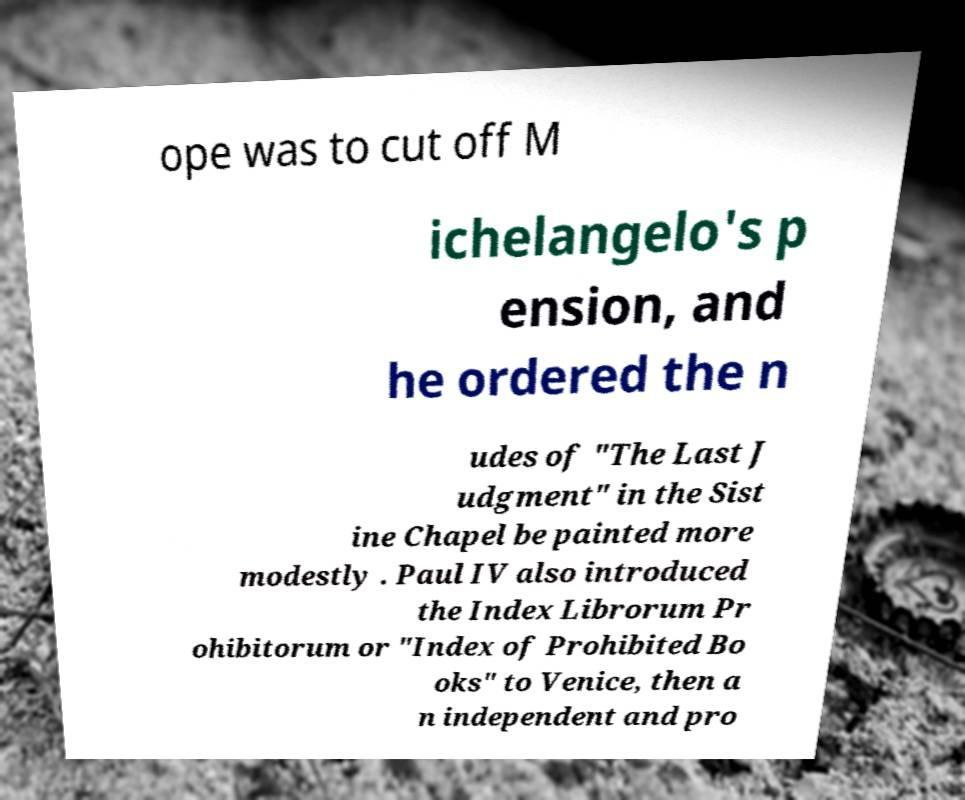Could you assist in decoding the text presented in this image and type it out clearly? ope was to cut off M ichelangelo's p ension, and he ordered the n udes of "The Last J udgment" in the Sist ine Chapel be painted more modestly . Paul IV also introduced the Index Librorum Pr ohibitorum or "Index of Prohibited Bo oks" to Venice, then a n independent and pro 